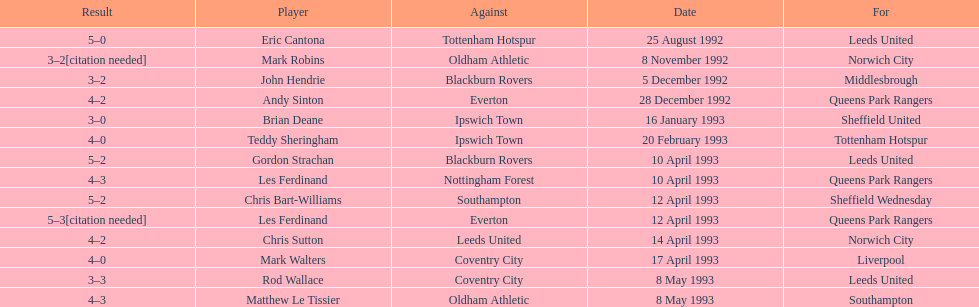Who did southampton compete against on may 8th, 1993? Oldham Athletic. 